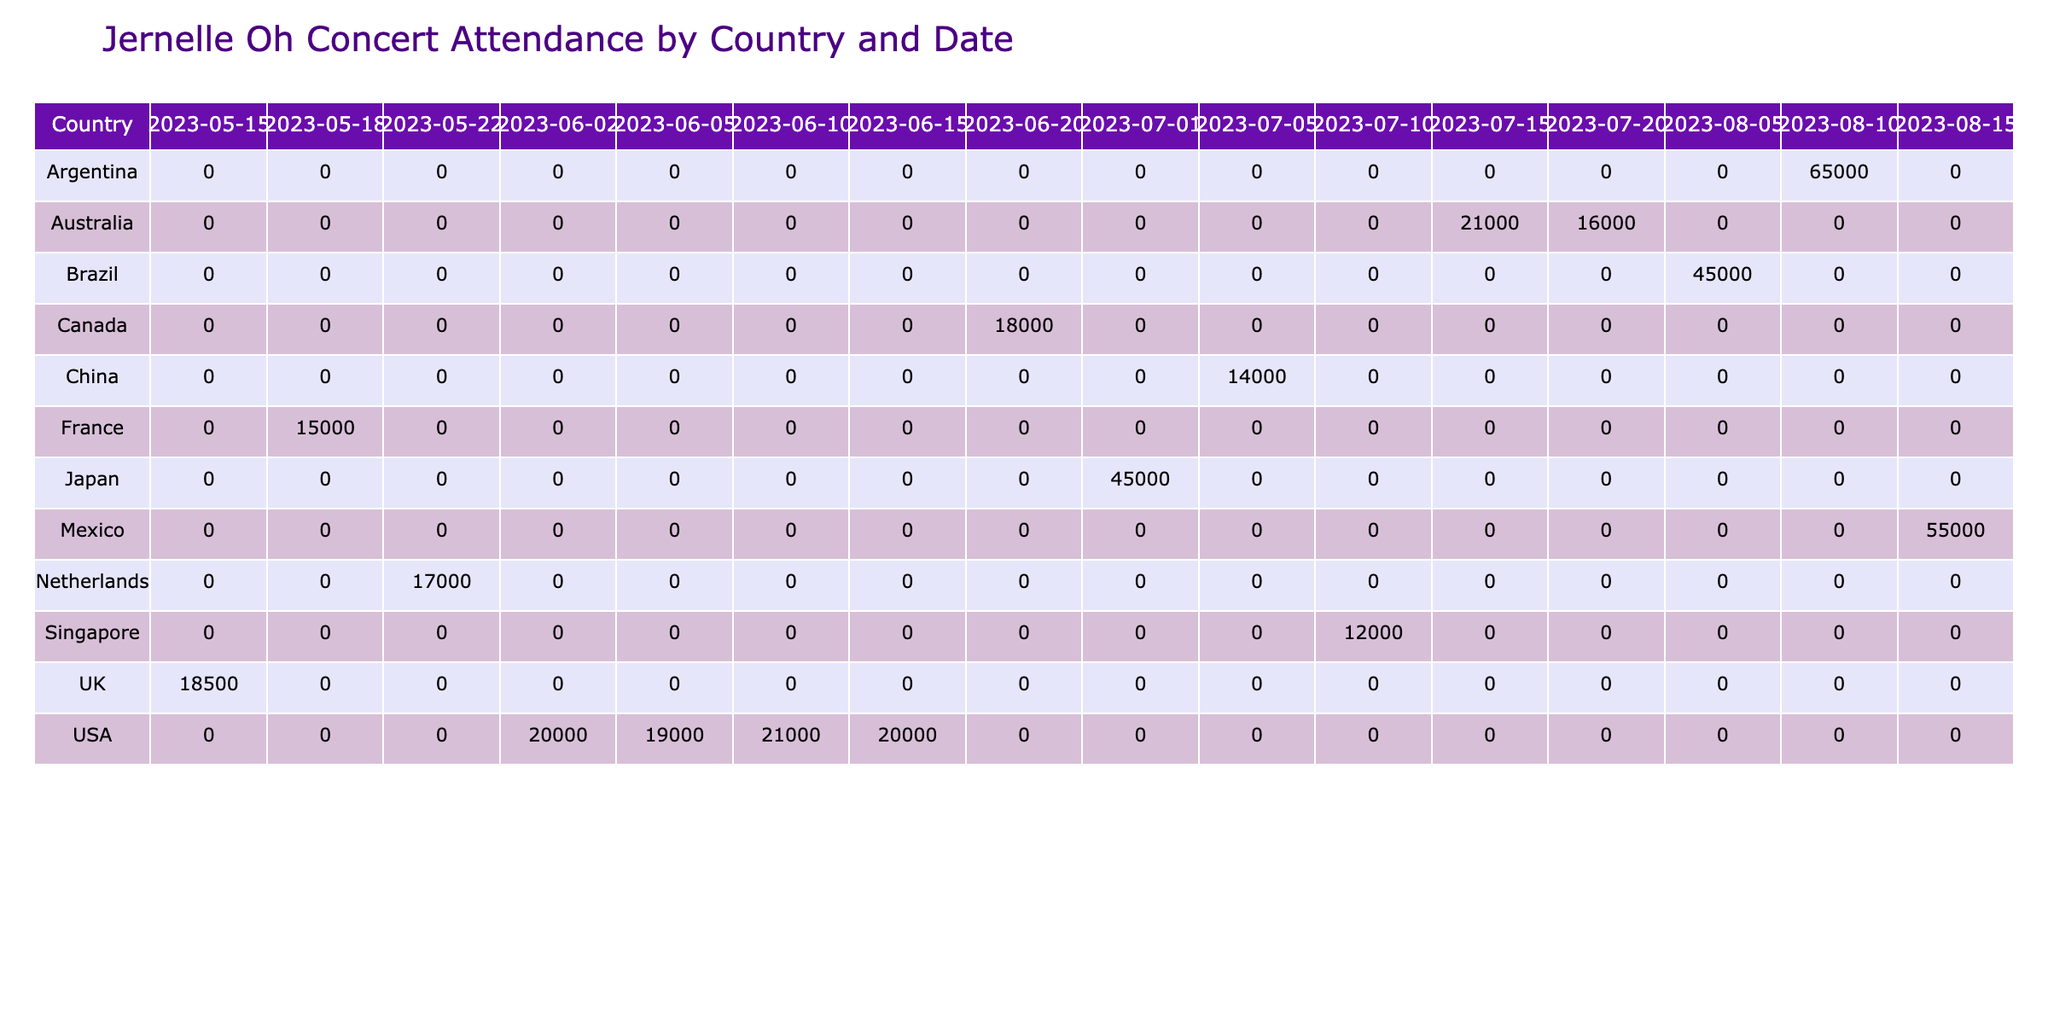What is the highest concert attendance in this table? The highest attendance is found in Mexico City on August 15, 2023, with 55,000 attendees.
Answer: 55,000 Which country had the lowest attendance for Jernelle Oh's concerts? To find the country with the lowest attendance, we can compare all the total attendances across different countries. The lowest attendance is in Singapore (12,000 attendees) on July 10, 2023.
Answer: Singapore What is the total attendance across all venues on June 2, 2023? On June 2, 2023, the only concert listed is at Madison Square Garden in New York City, which had an attendance of 20,000. Thus, the total attendance for that date is just 20,000.
Answer: 20,000 Did Jernelle Oh perform in more venues in the USA or outside the USA? Counting the concerts, Jernelle Oh performed in 6 venues in the USA (New York City, Boston, Chicago, Los Angeles, Vancouver) and 6 venues outside the USA (London, Paris, Amsterdam, Tokyo, Hong Kong, Singapore, Sydney, Melbourne, Sao Paulo, Buenos Aires, Mexico City). Since both totals are equal, the answer is No.
Answer: No What is the average ticket price for concerts held in Australia? The concerts in Australia are at Qudos Bank Arena and Rod Laver Arena with ticket prices of 90 and 85 USD, respectively. The average ticket price is (90 + 85) / 2 = 87.5 USD.
Answer: 87.5 USD What is the difference in merchandise sales between the highest and lowest concert? The highest merchandise sales occurred in Buenos Aires on August 10, 2023, with 800,000 USD, while the lowest was in Singapore on July 10, 2023, with 220,000 USD. The difference is 800,000 - 220,000 = 580,000 USD.
Answer: 580,000 USD How many concerts had attendances exceeding 20,000? By examining the attendance figures in the table, we see that the concerts in Chicago (21,000), New York City (20,000), Los Angeles (20,000), Tokyo (45,000), Sydney (21,000), São Paulo (45,000), Buenos Aires (65,000), and Mexico City (55,000) all exceed 20,000. This totals to 8 concerts.
Answer: 8 Did Jernelle Oh have concerts in Europe before June? The concerts listed in Europe before June are on May 15 in London and May 18 in Paris. Therefore, yes, Jernelle Oh had concerts in Europe before June.
Answer: Yes 